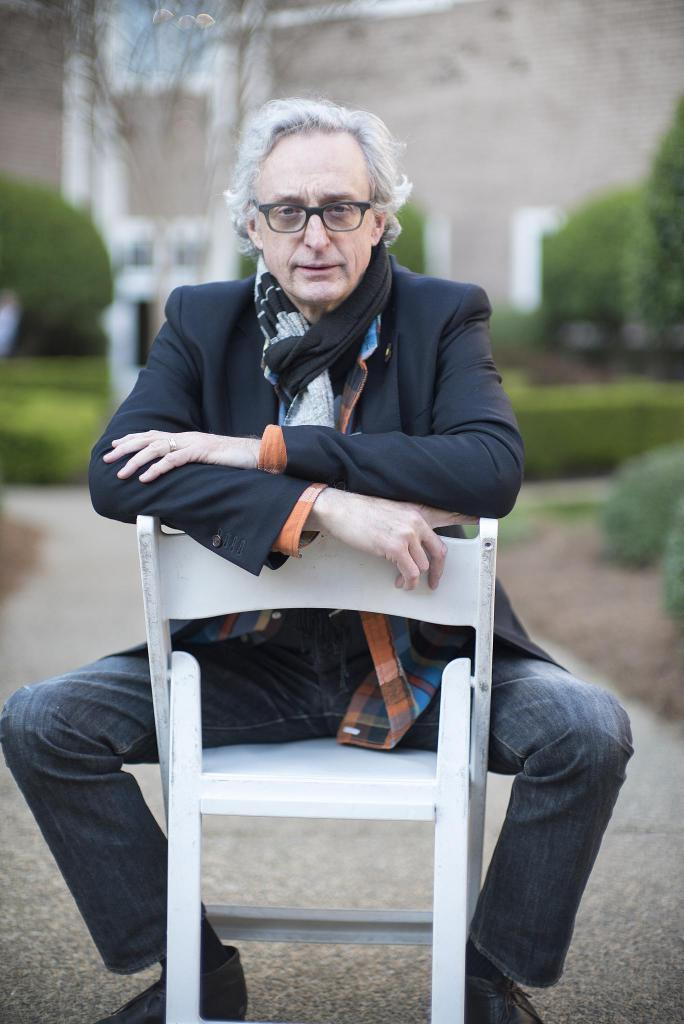What is the person in the image wearing? There is a person wearing a suit in the image. What is the person doing in the image? The person is sitting in a white sofa. What can be seen in the background of the image? There are trees visible in the background of the image. What type of voice can be heard coming from the person in the image? There is no indication of any sound or voice in the image, as it is a still photograph. Is the person in the image about to smash a cake? There is no cake or any indication of a smashing action in the image. 